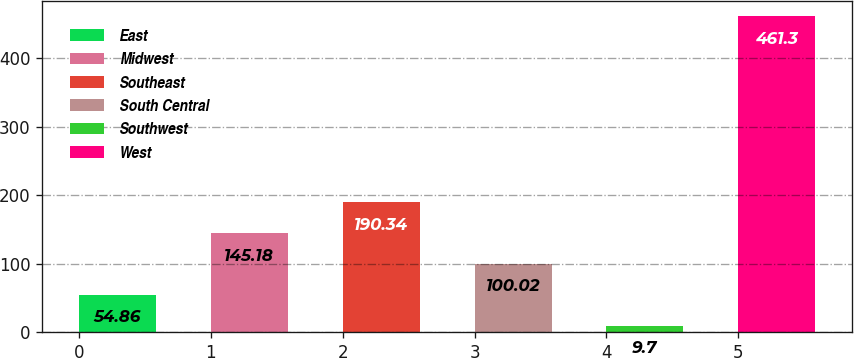Convert chart to OTSL. <chart><loc_0><loc_0><loc_500><loc_500><bar_chart><fcel>East<fcel>Midwest<fcel>Southeast<fcel>South Central<fcel>Southwest<fcel>West<nl><fcel>54.86<fcel>145.18<fcel>190.34<fcel>100.02<fcel>9.7<fcel>461.3<nl></chart> 